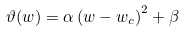Convert formula to latex. <formula><loc_0><loc_0><loc_500><loc_500>\vartheta ( w ) = \alpha \left ( w - w _ { c } \right ) ^ { 2 } + \beta</formula> 